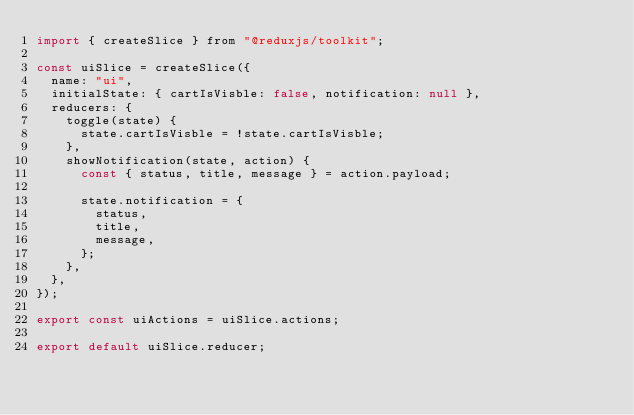Convert code to text. <code><loc_0><loc_0><loc_500><loc_500><_JavaScript_>import { createSlice } from "@reduxjs/toolkit";

const uiSlice = createSlice({
  name: "ui",
  initialState: { cartIsVisble: false, notification: null },
  reducers: {
    toggle(state) {
      state.cartIsVisble = !state.cartIsVisble;
    },
    showNotification(state, action) {
      const { status, title, message } = action.payload;

      state.notification = {
        status,
        title,
        message,
      };
    },
  },
});

export const uiActions = uiSlice.actions;

export default uiSlice.reducer;
</code> 